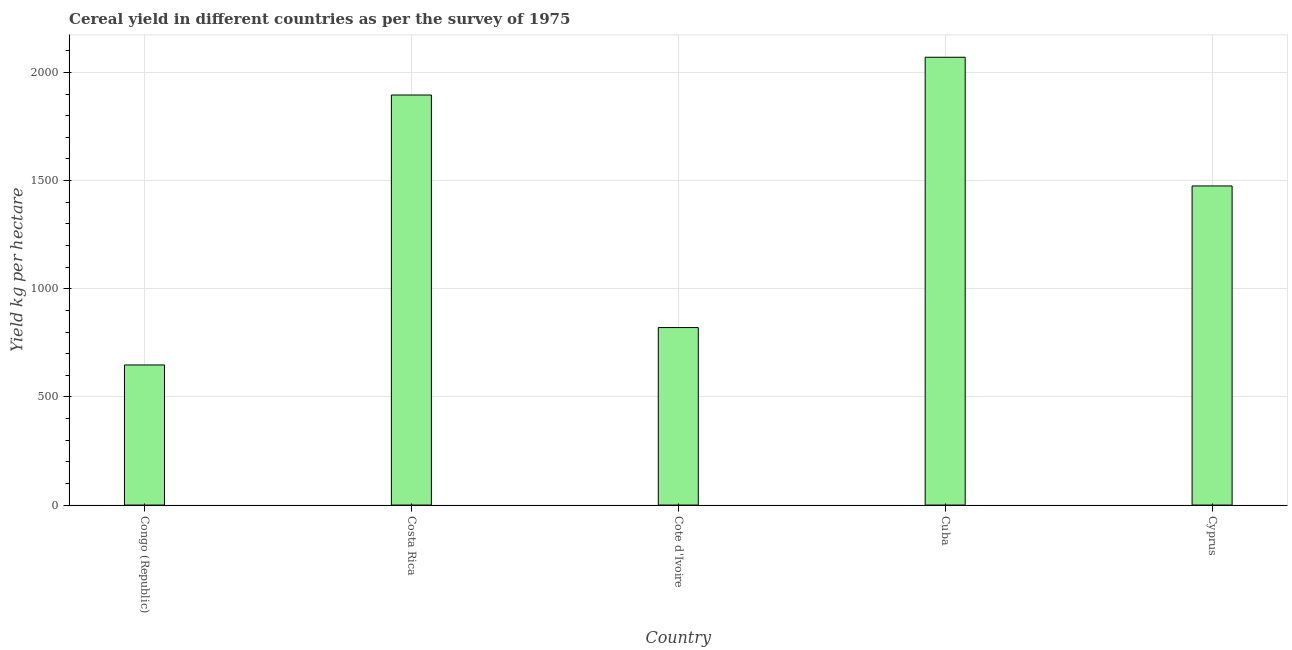What is the title of the graph?
Offer a very short reply. Cereal yield in different countries as per the survey of 1975. What is the label or title of the X-axis?
Ensure brevity in your answer.  Country. What is the label or title of the Y-axis?
Give a very brief answer. Yield kg per hectare. What is the cereal yield in Cyprus?
Provide a short and direct response. 1475.27. Across all countries, what is the maximum cereal yield?
Provide a short and direct response. 2070.13. Across all countries, what is the minimum cereal yield?
Offer a very short reply. 647.68. In which country was the cereal yield maximum?
Your answer should be very brief. Cuba. In which country was the cereal yield minimum?
Give a very brief answer. Congo (Republic). What is the sum of the cereal yield?
Provide a short and direct response. 6909.26. What is the difference between the cereal yield in Congo (Republic) and Costa Rica?
Ensure brevity in your answer.  -1247.95. What is the average cereal yield per country?
Offer a very short reply. 1381.85. What is the median cereal yield?
Your answer should be compact. 1475.27. In how many countries, is the cereal yield greater than 500 kg per hectare?
Keep it short and to the point. 5. What is the ratio of the cereal yield in Costa Rica to that in Cyprus?
Provide a succinct answer. 1.28. Is the cereal yield in Congo (Republic) less than that in Cyprus?
Make the answer very short. Yes. Is the difference between the cereal yield in Congo (Republic) and Cyprus greater than the difference between any two countries?
Make the answer very short. No. What is the difference between the highest and the second highest cereal yield?
Your response must be concise. 174.5. What is the difference between the highest and the lowest cereal yield?
Your response must be concise. 1422.45. In how many countries, is the cereal yield greater than the average cereal yield taken over all countries?
Give a very brief answer. 3. Are all the bars in the graph horizontal?
Ensure brevity in your answer.  No. How many countries are there in the graph?
Your answer should be very brief. 5. Are the values on the major ticks of Y-axis written in scientific E-notation?
Give a very brief answer. No. What is the Yield kg per hectare in Congo (Republic)?
Your answer should be compact. 647.68. What is the Yield kg per hectare of Costa Rica?
Offer a very short reply. 1895.63. What is the Yield kg per hectare of Cote d'Ivoire?
Offer a very short reply. 820.54. What is the Yield kg per hectare in Cuba?
Provide a short and direct response. 2070.13. What is the Yield kg per hectare in Cyprus?
Provide a short and direct response. 1475.27. What is the difference between the Yield kg per hectare in Congo (Republic) and Costa Rica?
Give a very brief answer. -1247.95. What is the difference between the Yield kg per hectare in Congo (Republic) and Cote d'Ivoire?
Your answer should be very brief. -172.86. What is the difference between the Yield kg per hectare in Congo (Republic) and Cuba?
Offer a very short reply. -1422.45. What is the difference between the Yield kg per hectare in Congo (Republic) and Cyprus?
Ensure brevity in your answer.  -827.59. What is the difference between the Yield kg per hectare in Costa Rica and Cote d'Ivoire?
Your answer should be compact. 1075.09. What is the difference between the Yield kg per hectare in Costa Rica and Cuba?
Provide a short and direct response. -174.5. What is the difference between the Yield kg per hectare in Costa Rica and Cyprus?
Provide a succinct answer. 420.36. What is the difference between the Yield kg per hectare in Cote d'Ivoire and Cuba?
Provide a succinct answer. -1249.59. What is the difference between the Yield kg per hectare in Cote d'Ivoire and Cyprus?
Your answer should be very brief. -654.73. What is the difference between the Yield kg per hectare in Cuba and Cyprus?
Your answer should be very brief. 594.86. What is the ratio of the Yield kg per hectare in Congo (Republic) to that in Costa Rica?
Give a very brief answer. 0.34. What is the ratio of the Yield kg per hectare in Congo (Republic) to that in Cote d'Ivoire?
Offer a terse response. 0.79. What is the ratio of the Yield kg per hectare in Congo (Republic) to that in Cuba?
Your answer should be compact. 0.31. What is the ratio of the Yield kg per hectare in Congo (Republic) to that in Cyprus?
Make the answer very short. 0.44. What is the ratio of the Yield kg per hectare in Costa Rica to that in Cote d'Ivoire?
Give a very brief answer. 2.31. What is the ratio of the Yield kg per hectare in Costa Rica to that in Cuba?
Offer a terse response. 0.92. What is the ratio of the Yield kg per hectare in Costa Rica to that in Cyprus?
Make the answer very short. 1.28. What is the ratio of the Yield kg per hectare in Cote d'Ivoire to that in Cuba?
Offer a very short reply. 0.4. What is the ratio of the Yield kg per hectare in Cote d'Ivoire to that in Cyprus?
Give a very brief answer. 0.56. What is the ratio of the Yield kg per hectare in Cuba to that in Cyprus?
Ensure brevity in your answer.  1.4. 